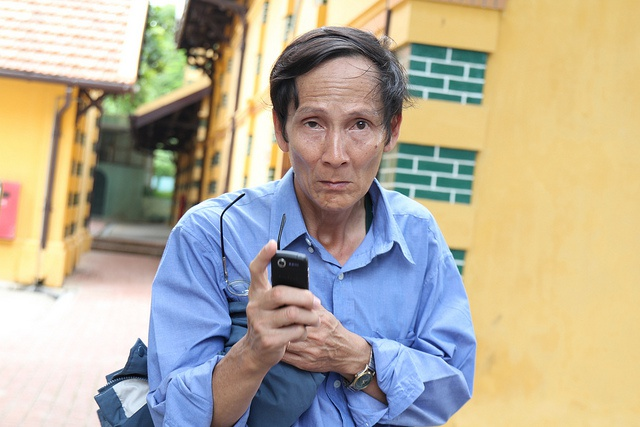Describe the objects in this image and their specific colors. I can see people in beige, lightblue, darkgray, and gray tones, handbag in beige, blue, navy, gray, and lightgray tones, and cell phone in beige, black, gray, and lightblue tones in this image. 